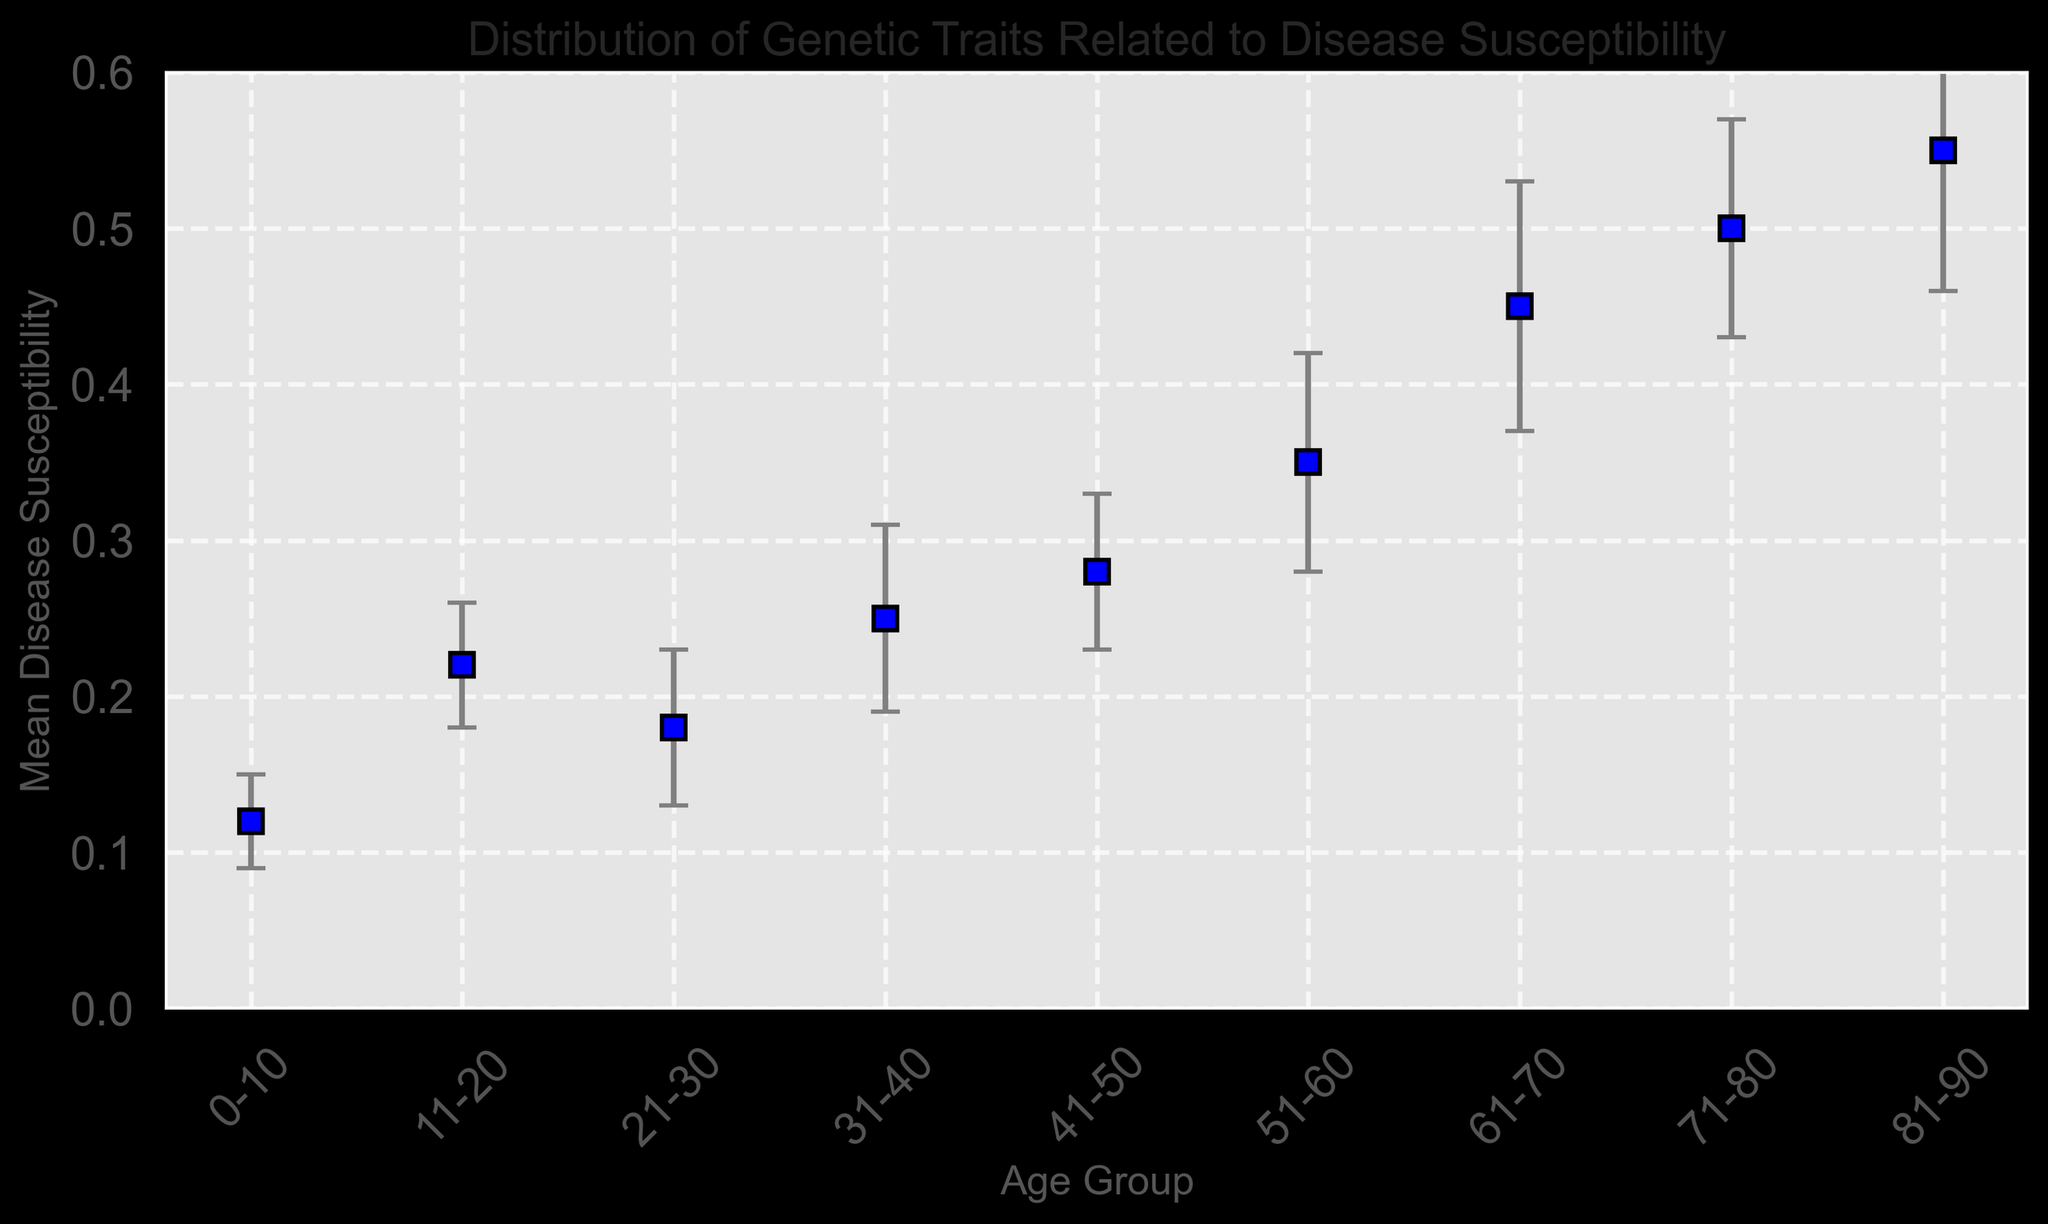What age group has the highest mean disease susceptibility? Looking at the figure, the highest point on the y-axis corresponds to the age group 81-90.
Answer: 81-90 Which age group shows the largest error bar in terms of disease susceptibility? The largest error bar is associated with the age group 81-90, which extends the highest vertically.
Answer: 81-90 Is the mean disease susceptibility higher in the 31-40 age group or the 21-30 age group? Comparing the points on the y-axis, the 31-40 group is higher at approximately 0.25, while the 21-30 group is at about 0.18.
Answer: 31-40 How does the mean disease susceptibility of the 0-10 age group compare to that of the 51-60 age group? The mean for the 0-10 group is around 0.12, whereas for the 51-60 group it's approximately 0.35. Therefore, the 51-60 group has higher mean susceptibility.
Answer: 51-60 Which age group has a mean disease susceptibility of about 0.22? On the y-axis, the value 0.22 aligns with the 11-20 age group.
Answer: 11-20 By how much does the mean disease susceptibility increase from the 0-10 age group to the 41-50 age group? The mean susceptibility for the 0-10 group is 0.12, and for the 41-50 group it's 0.28. The increase is 0.28 - 0.12.
Answer: 0.16 What is the overall trend of disease susceptibility as age increases? Observing the points on the plot, the mean disease susceptibility generally increases as age groups progress from younger to older.
Answer: Increases with age Which two consecutive age groups show the largest increase in mean disease susceptibility? The largest increase between consecutive points is between the age groups 51-60 (mean ~0.35) and 61-70 (mean ~0.45).
Answer: 51-60 to 61-70 What is the average mean disease susceptibility of the age groups 21-30, 31-40, and 41-50? The mean susceptibilities are 0.18, 0.25, and 0.28, respectively. The average is calculated as (0.18 + 0.25 + 0.28)/3.
Answer: 0.24 How does the uncertainty (standard deviation) compare for the 61-70 and 41-50 age groups? The error bars indicate the standard deviations: 61-70 has a larger error bar (0.08) compared to 41-50 (0.05).
Answer: 61-70 has higher uncertainty 